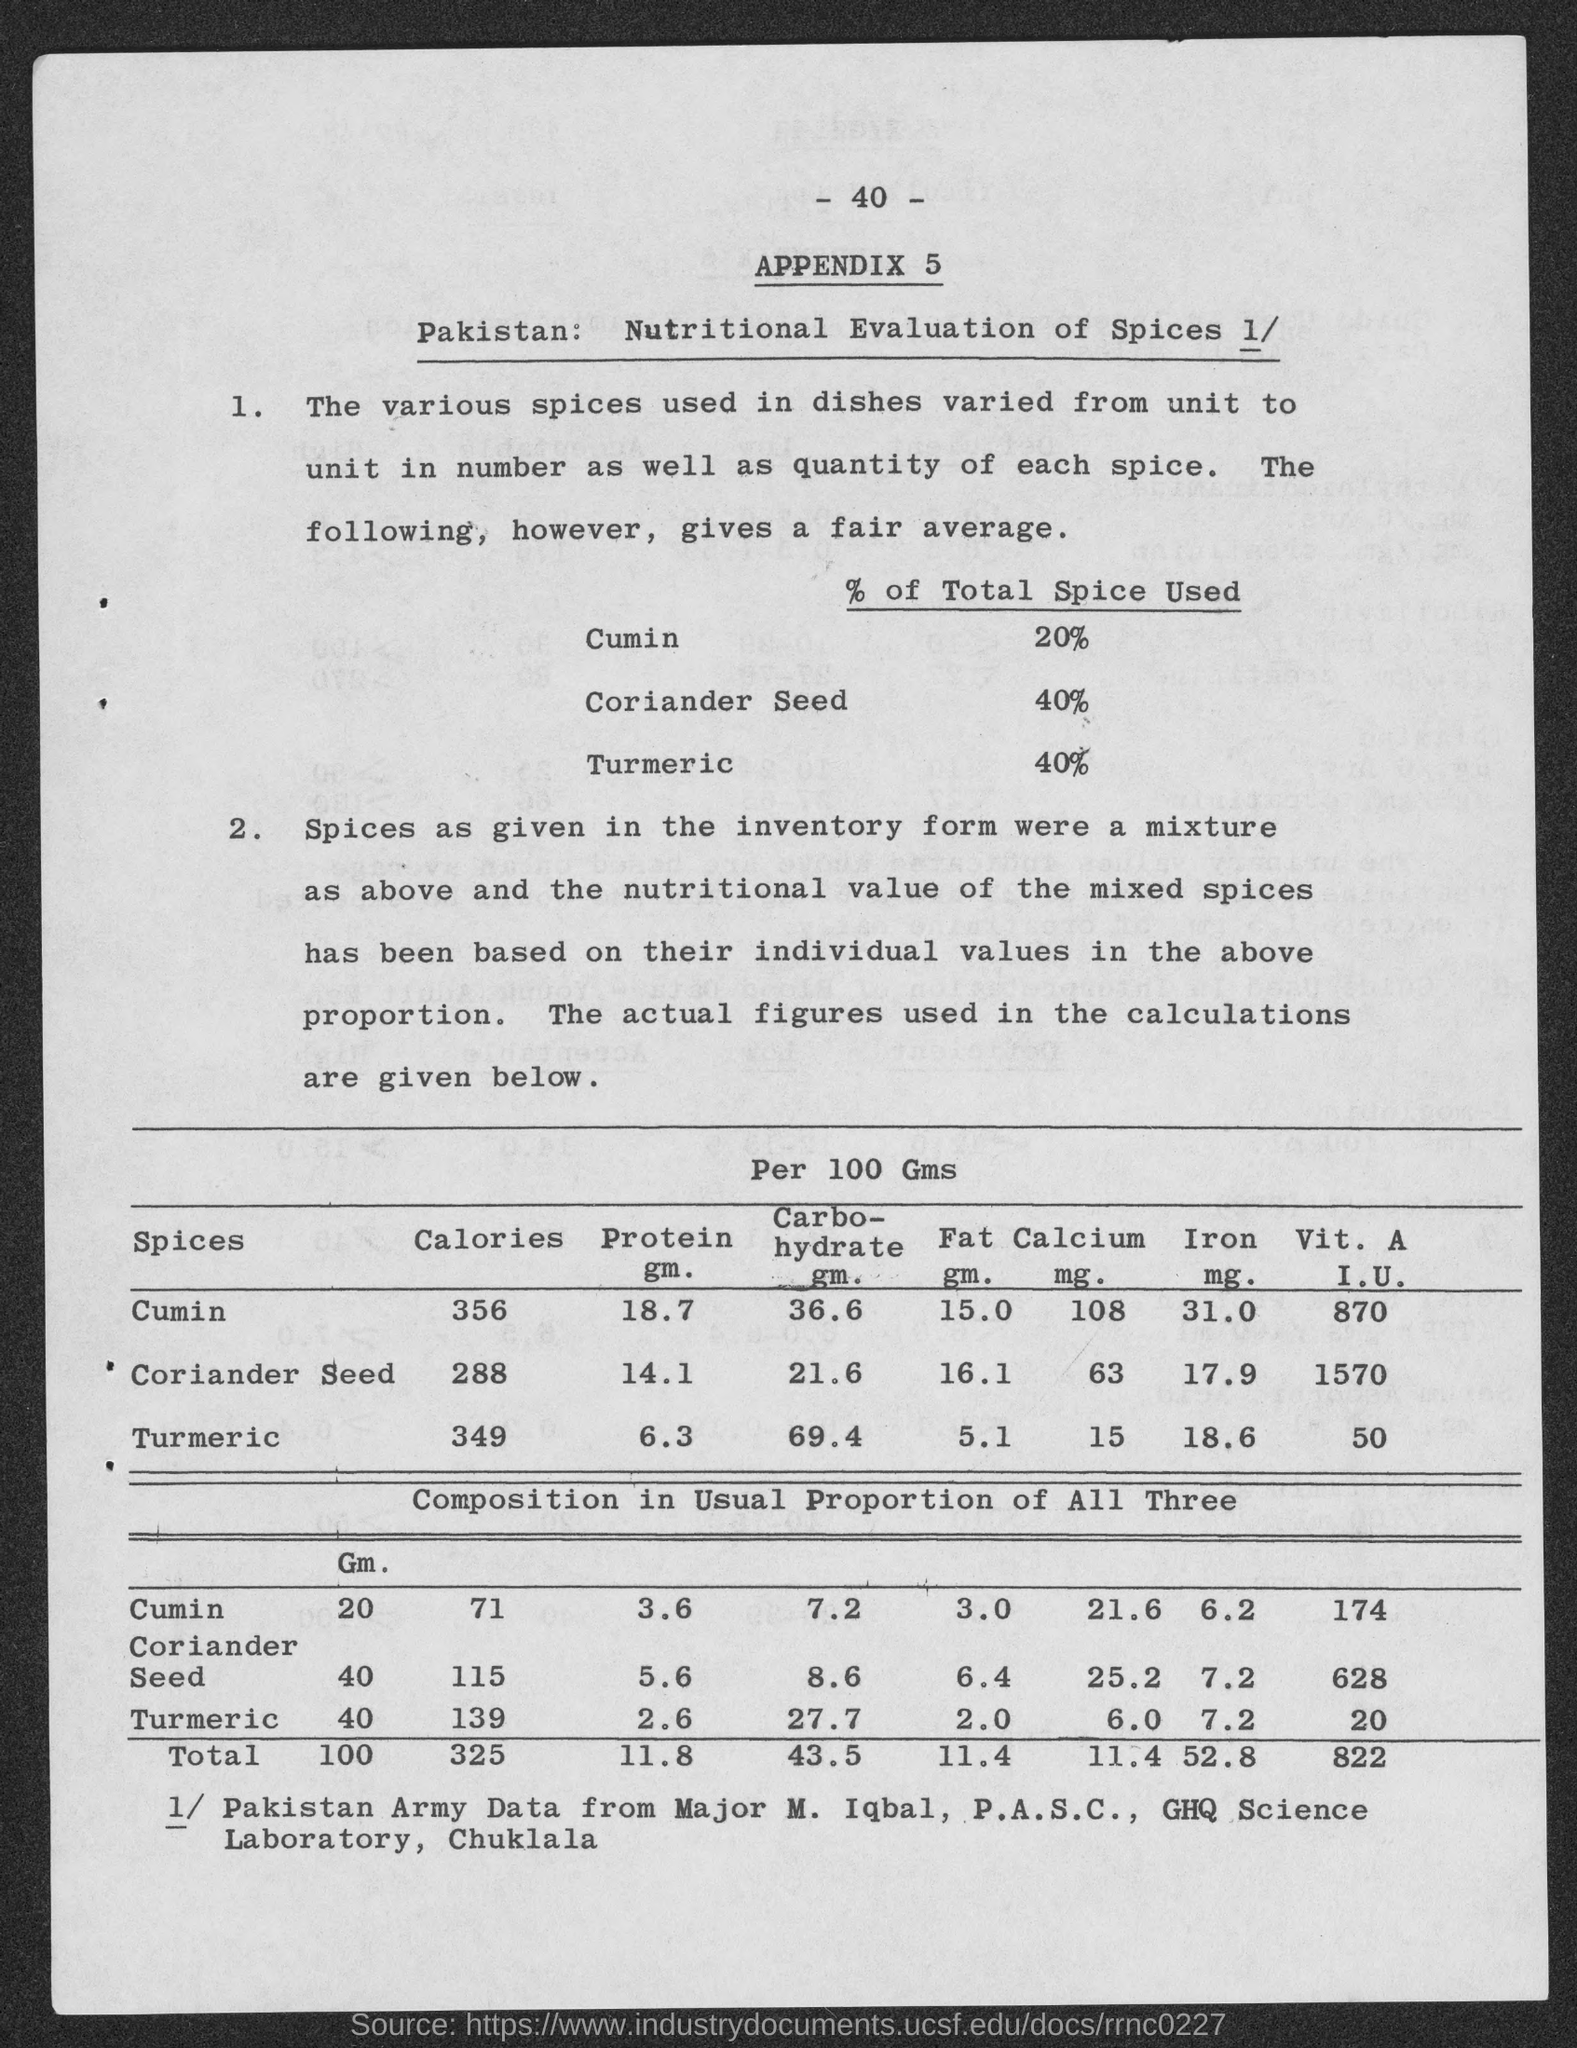What is the number at top of the page?
Provide a short and direct response. 40. What is the appendix no.?
Make the answer very short. 5. What is the % total spice used for cumin?
Your answer should be compact. 20%. What is the % total spice used for  coriander seed?
Provide a succinct answer. 40%. What is the % total spice used for turmeric ?
Offer a terse response. 40%. 